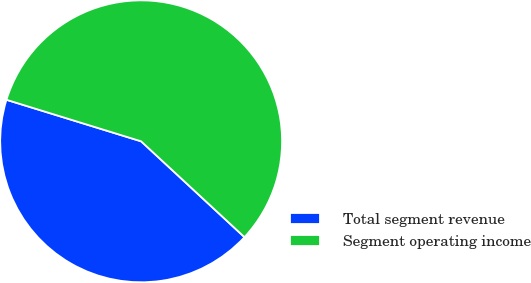Convert chart. <chart><loc_0><loc_0><loc_500><loc_500><pie_chart><fcel>Total segment revenue<fcel>Segment operating income<nl><fcel>42.86%<fcel>57.14%<nl></chart> 